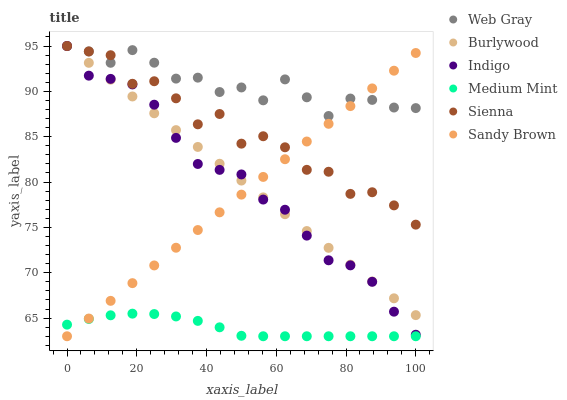Does Medium Mint have the minimum area under the curve?
Answer yes or no. Yes. Does Web Gray have the maximum area under the curve?
Answer yes or no. Yes. Does Indigo have the minimum area under the curve?
Answer yes or no. No. Does Indigo have the maximum area under the curve?
Answer yes or no. No. Is Burlywood the smoothest?
Answer yes or no. Yes. Is Sienna the roughest?
Answer yes or no. Yes. Is Web Gray the smoothest?
Answer yes or no. No. Is Web Gray the roughest?
Answer yes or no. No. Does Medium Mint have the lowest value?
Answer yes or no. Yes. Does Indigo have the lowest value?
Answer yes or no. No. Does Sienna have the highest value?
Answer yes or no. Yes. Does Sandy Brown have the highest value?
Answer yes or no. No. Is Medium Mint less than Sienna?
Answer yes or no. Yes. Is Indigo greater than Medium Mint?
Answer yes or no. Yes. Does Burlywood intersect Sandy Brown?
Answer yes or no. Yes. Is Burlywood less than Sandy Brown?
Answer yes or no. No. Is Burlywood greater than Sandy Brown?
Answer yes or no. No. Does Medium Mint intersect Sienna?
Answer yes or no. No. 